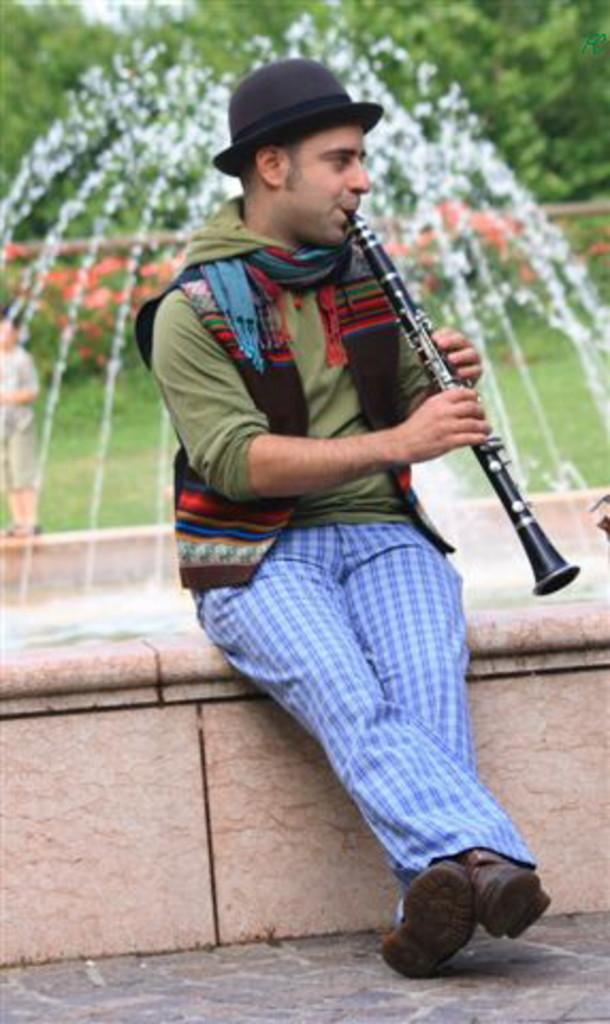Who is the main subject in the image? There is a boy in the image. What is the boy wearing on his upper body? The boy is wearing a green t-shirt and a jacket. What is on the boy's head? The boy is wearing a cap on his head. What is the boy doing in the image? The boy is playing a black flute. What can be seen in the background of the image? There is a water fountain and plants in the background of the image. What type of quilt is draped over the water fountain in the image? There is no quilt present in the image; the water fountain is not covered by any fabric. How does the boy use the sail to play the flute in the image? The boy is not using a sail to play the flute in the image; he is playing a black flute without any additional objects. 